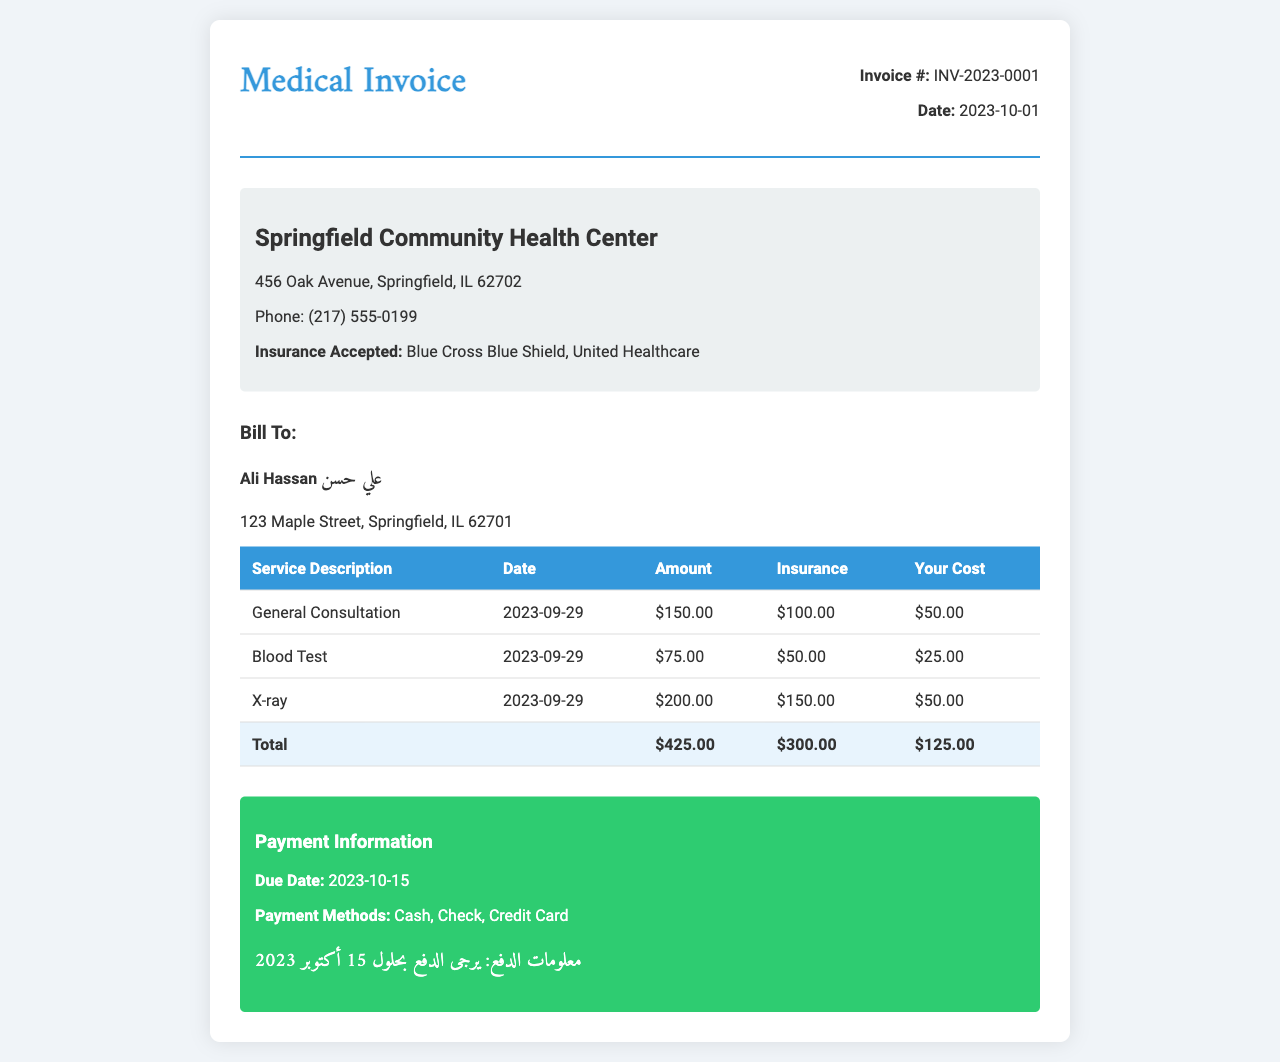What is the invoice number? The invoice number is listed in the document under "Invoice #".
Answer: INV-2023-0001 What is the total amount before insurance? The total amount is the sum of all services rendered listed in the table.
Answer: $425.00 What is the insurance coverage for the X-ray service? The insurance coverage for the X-ray service is specified in the table under the "Insurance" column.
Answer: $150.00 What is your out-of-pocket cost for the Blood Test? The out-of-pocket cost is the amount you are responsible for paying after insurance has been applied.
Answer: $25.00 What is the due date for payment? The due date for payment is mentioned in the "Payment Information" section of the document.
Answer: 2023-10-15 What services were rendered on 2023-09-29? The services rendered on 2023-09-29 are listed in the table under "Service Description".
Answer: General Consultation, Blood Test, X-ray How much will you pay for the General Consultation? The amount you will pay for the General Consultation is specified in the "Your Cost" column of the table.
Answer: $50.00 What is the provider's phone number? The provider's phone number is listed in the document under the provider information section.
Answer: (217) 555-0199 